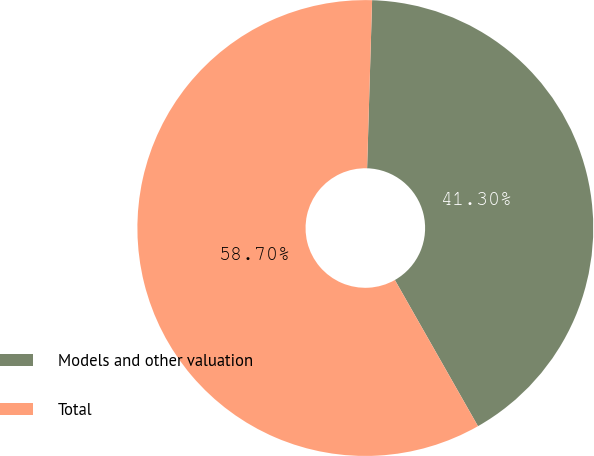Convert chart to OTSL. <chart><loc_0><loc_0><loc_500><loc_500><pie_chart><fcel>Models and other valuation<fcel>Total<nl><fcel>41.3%<fcel>58.7%<nl></chart> 